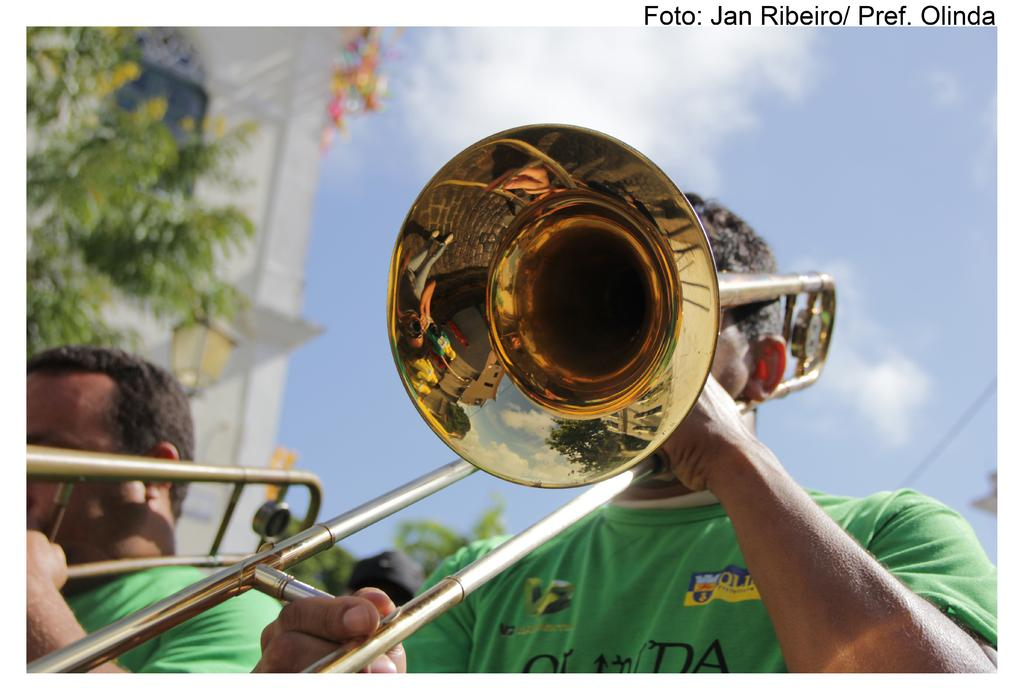How many people are in the image? There are two persons in the image. What are the persons doing in the image? The persons are playing musical instruments. What can be seen on the left side of the image? There is a tree on the left side of the image. What is visible in the background of the image? There is a building in the background of the image. What is visible at the top of the image? The sky is visible at the top of the image. What can be observed in the sky? There are clouds in the sky. Can you tell me what the tiger is writing on the building in the image? There is no tiger present in the image, and therefore no writing can be observed. Who is the daughter of the person playing the guitar in the image? There is no mention of a daughter or any familial relationships in the image. 